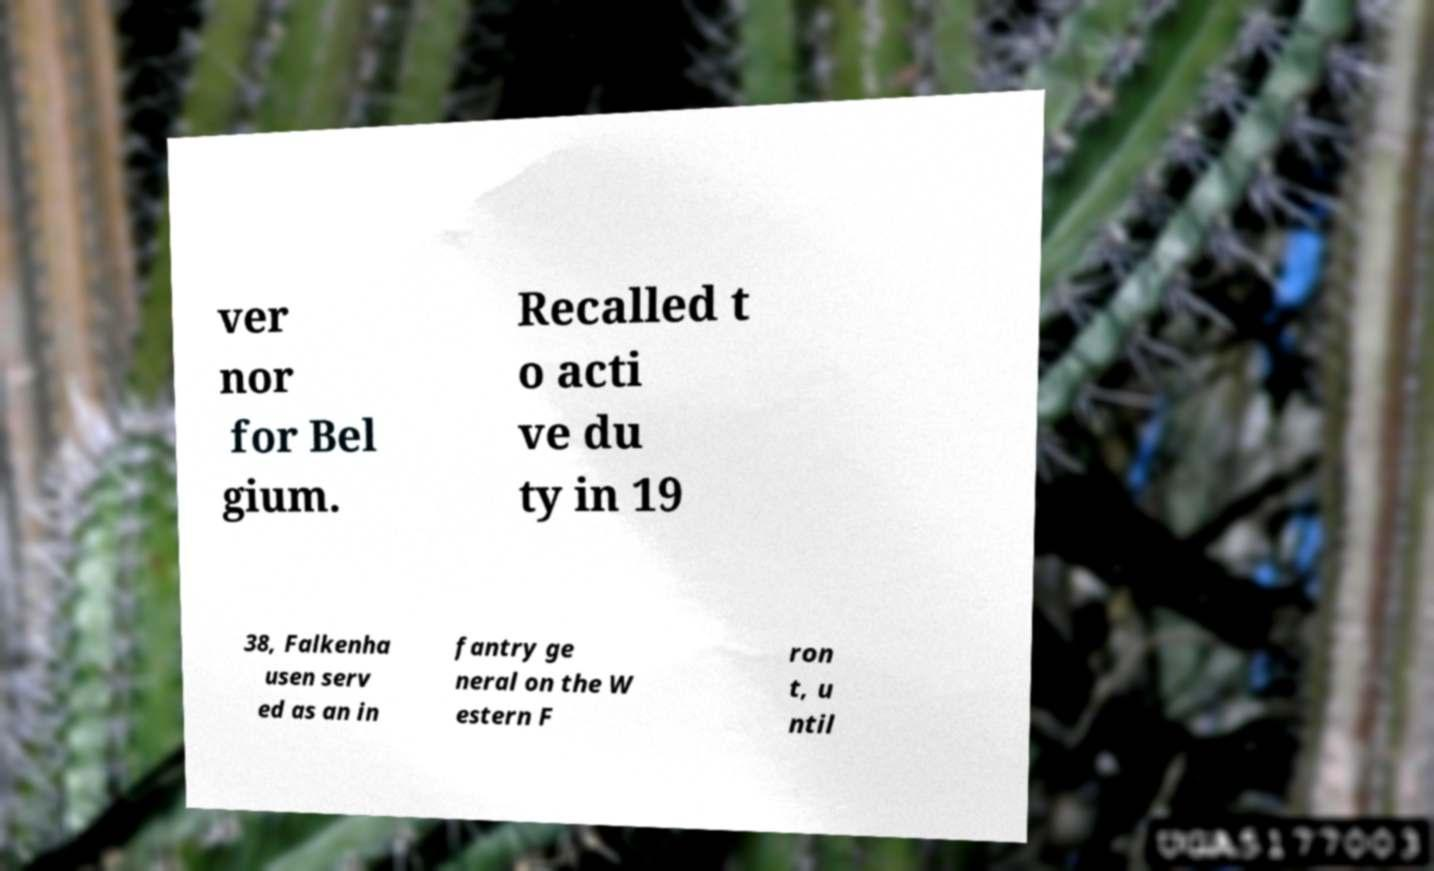There's text embedded in this image that I need extracted. Can you transcribe it verbatim? ver nor for Bel gium. Recalled t o acti ve du ty in 19 38, Falkenha usen serv ed as an in fantry ge neral on the W estern F ron t, u ntil 